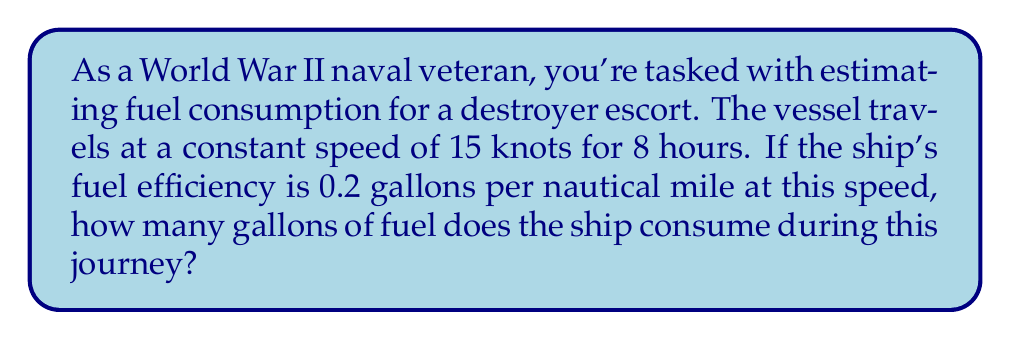Can you answer this question? To solve this problem, we'll follow these steps:

1. Calculate the distance traveled:
   $$ \text{Distance} = \text{Speed} \times \text{Time} $$
   $$ \text{Distance} = 15 \text{ knots} \times 8 \text{ hours} = 120 \text{ nautical miles} $$

2. Calculate fuel consumption:
   $$ \text{Fuel Consumed} = \text{Distance} \times \text{Fuel Efficiency} $$
   $$ \text{Fuel Consumed} = 120 \text{ nautical miles} \times 0.2 \text{ gallons/nautical mile} $$
   $$ \text{Fuel Consumed} = 24 \text{ gallons} $$

Therefore, the destroyer escort consumes 24 gallons of fuel during this 8-hour journey.
Answer: 24 gallons 